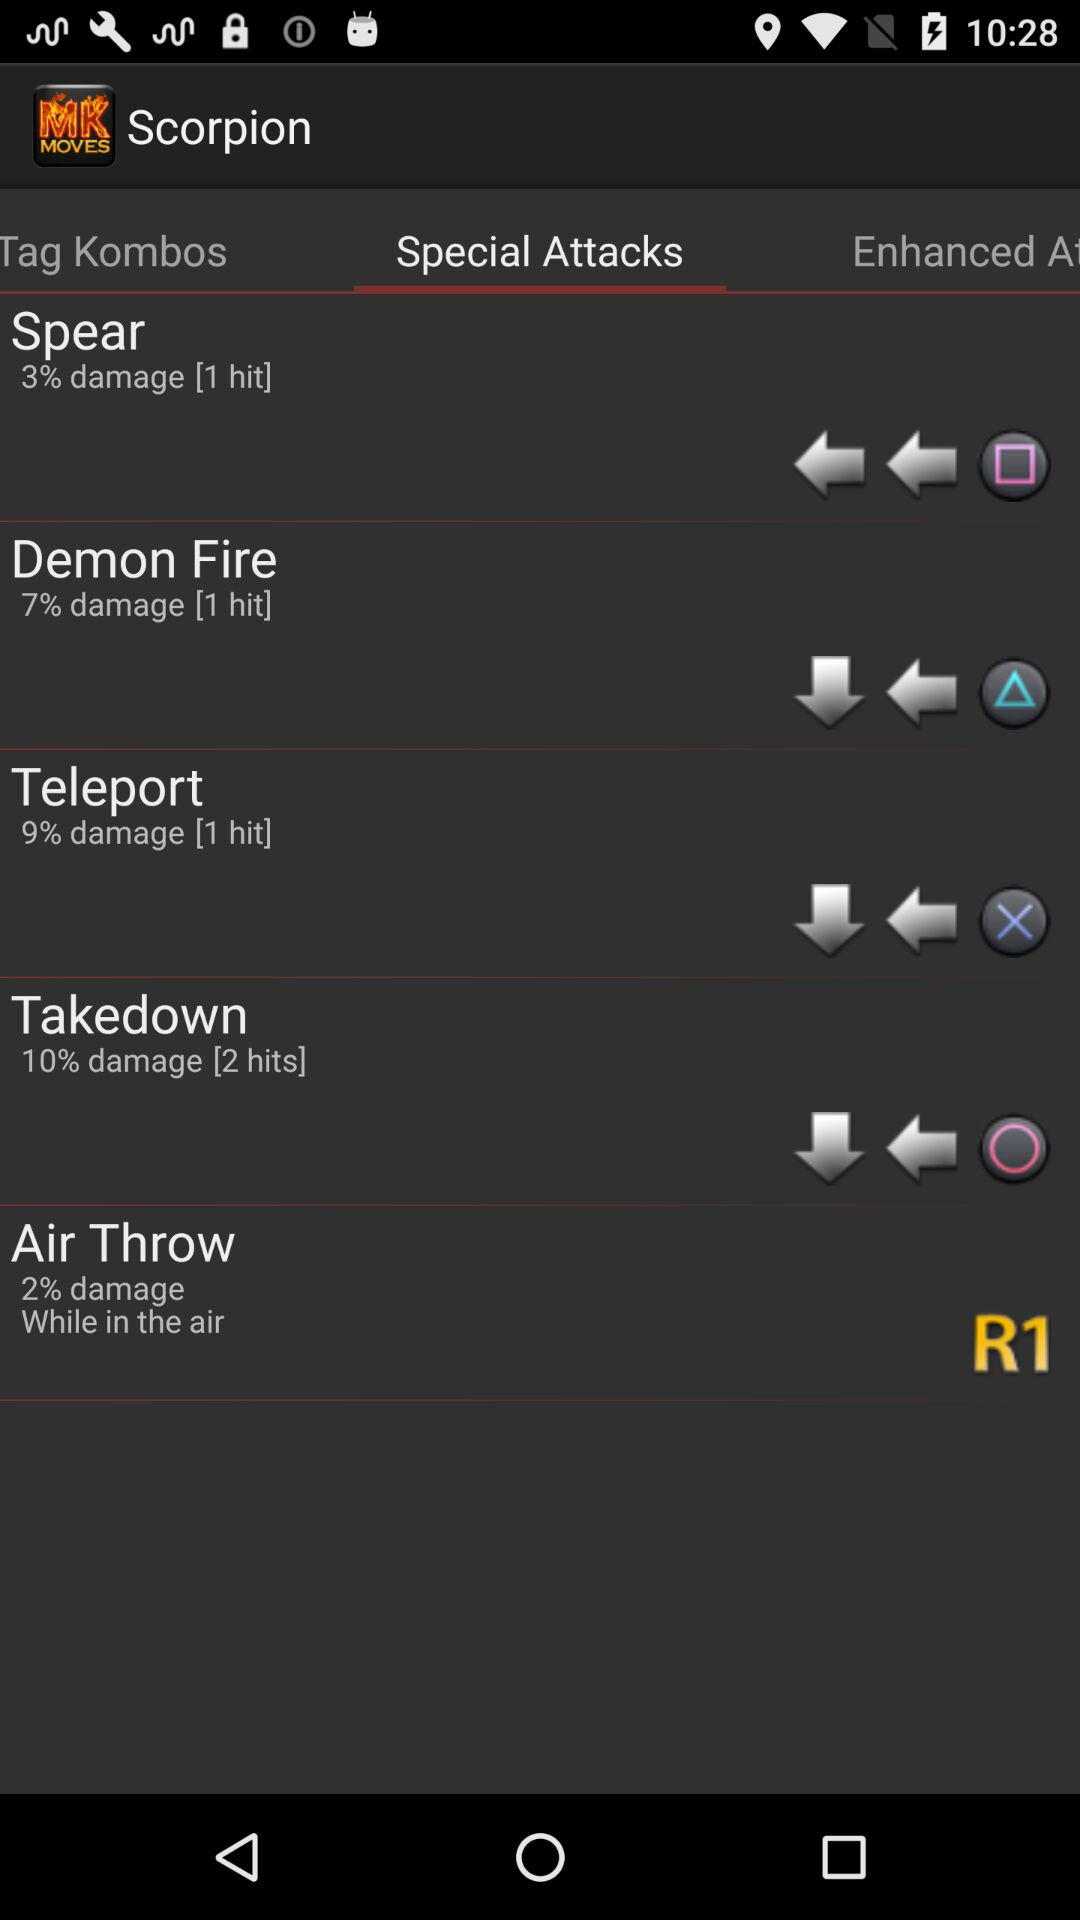What is the damage percentage of "Air Throw" while it is in the air? The damage percentage of "Air Throw" while it is in the air is 2. 